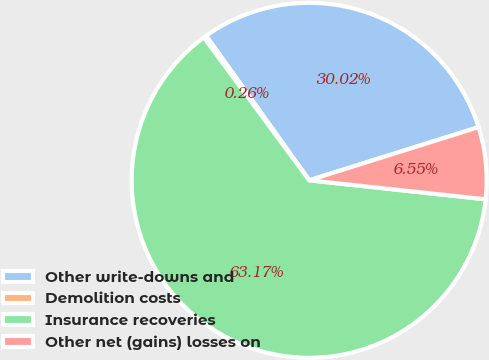<chart> <loc_0><loc_0><loc_500><loc_500><pie_chart><fcel>Other write-downs and<fcel>Demolition costs<fcel>Insurance recoveries<fcel>Other net (gains) losses on<nl><fcel>30.02%<fcel>0.26%<fcel>63.18%<fcel>6.55%<nl></chart> 